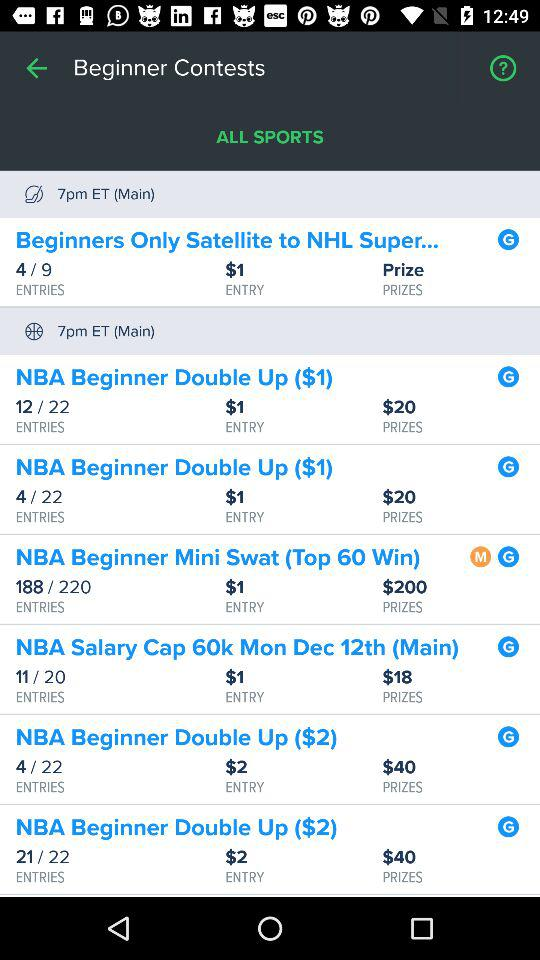What's the number of entries filled out of 22 in the "NBA Beginner Double Up ($1)" contest? The number of entries is 12 and 4. 